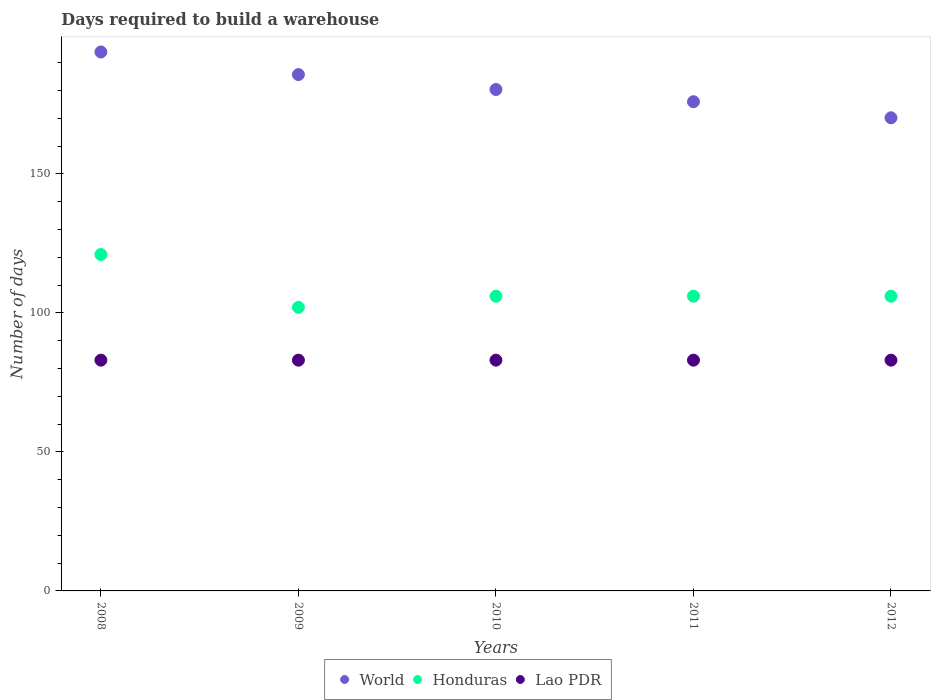What is the days required to build a warehouse in in Honduras in 2011?
Ensure brevity in your answer.  106. Across all years, what is the maximum days required to build a warehouse in in Lao PDR?
Give a very brief answer. 83. Across all years, what is the minimum days required to build a warehouse in in Honduras?
Offer a terse response. 102. What is the total days required to build a warehouse in in World in the graph?
Your response must be concise. 906.04. What is the difference between the days required to build a warehouse in in World in 2011 and that in 2012?
Provide a short and direct response. 5.78. What is the difference between the days required to build a warehouse in in Honduras in 2008 and the days required to build a warehouse in in Lao PDR in 2009?
Offer a very short reply. 38. What is the average days required to build a warehouse in in World per year?
Your answer should be compact. 181.21. In the year 2008, what is the difference between the days required to build a warehouse in in Honduras and days required to build a warehouse in in World?
Provide a short and direct response. -72.84. In how many years, is the days required to build a warehouse in in World greater than 140 days?
Ensure brevity in your answer.  5. Is the difference between the days required to build a warehouse in in Honduras in 2010 and 2011 greater than the difference between the days required to build a warehouse in in World in 2010 and 2011?
Offer a terse response. No. What is the difference between the highest and the second highest days required to build a warehouse in in World?
Your response must be concise. 8.13. What is the difference between the highest and the lowest days required to build a warehouse in in Honduras?
Provide a succinct answer. 19. In how many years, is the days required to build a warehouse in in Honduras greater than the average days required to build a warehouse in in Honduras taken over all years?
Provide a short and direct response. 1. Is it the case that in every year, the sum of the days required to build a warehouse in in World and days required to build a warehouse in in Honduras  is greater than the days required to build a warehouse in in Lao PDR?
Provide a short and direct response. Yes. Is the days required to build a warehouse in in Honduras strictly greater than the days required to build a warehouse in in Lao PDR over the years?
Your response must be concise. Yes. How many dotlines are there?
Your response must be concise. 3. How many years are there in the graph?
Your response must be concise. 5. Does the graph contain grids?
Your answer should be very brief. No. How are the legend labels stacked?
Make the answer very short. Horizontal. What is the title of the graph?
Give a very brief answer. Days required to build a warehouse. What is the label or title of the Y-axis?
Your answer should be compact. Number of days. What is the Number of days in World in 2008?
Provide a short and direct response. 193.84. What is the Number of days in Honduras in 2008?
Offer a very short reply. 121. What is the Number of days of Lao PDR in 2008?
Make the answer very short. 83. What is the Number of days of World in 2009?
Your answer should be very brief. 185.71. What is the Number of days in Honduras in 2009?
Your response must be concise. 102. What is the Number of days of World in 2010?
Offer a very short reply. 180.35. What is the Number of days of Honduras in 2010?
Your response must be concise. 106. What is the Number of days of World in 2011?
Provide a short and direct response. 175.96. What is the Number of days in Honduras in 2011?
Ensure brevity in your answer.  106. What is the Number of days of World in 2012?
Make the answer very short. 170.18. What is the Number of days in Honduras in 2012?
Offer a terse response. 106. What is the Number of days of Lao PDR in 2012?
Offer a terse response. 83. Across all years, what is the maximum Number of days of World?
Give a very brief answer. 193.84. Across all years, what is the maximum Number of days in Honduras?
Give a very brief answer. 121. Across all years, what is the minimum Number of days in World?
Offer a very short reply. 170.18. Across all years, what is the minimum Number of days of Honduras?
Your answer should be compact. 102. Across all years, what is the minimum Number of days in Lao PDR?
Your answer should be compact. 83. What is the total Number of days of World in the graph?
Offer a very short reply. 906.04. What is the total Number of days in Honduras in the graph?
Your answer should be very brief. 541. What is the total Number of days in Lao PDR in the graph?
Give a very brief answer. 415. What is the difference between the Number of days of World in 2008 and that in 2009?
Your answer should be very brief. 8.13. What is the difference between the Number of days in Lao PDR in 2008 and that in 2009?
Offer a terse response. 0. What is the difference between the Number of days in World in 2008 and that in 2010?
Make the answer very short. 13.49. What is the difference between the Number of days of Lao PDR in 2008 and that in 2010?
Offer a terse response. 0. What is the difference between the Number of days in World in 2008 and that in 2011?
Offer a very short reply. 17.89. What is the difference between the Number of days of Honduras in 2008 and that in 2011?
Offer a very short reply. 15. What is the difference between the Number of days of Lao PDR in 2008 and that in 2011?
Keep it short and to the point. 0. What is the difference between the Number of days in World in 2008 and that in 2012?
Offer a very short reply. 23.67. What is the difference between the Number of days in Honduras in 2008 and that in 2012?
Your answer should be compact. 15. What is the difference between the Number of days of World in 2009 and that in 2010?
Offer a very short reply. 5.36. What is the difference between the Number of days of Honduras in 2009 and that in 2010?
Your answer should be very brief. -4. What is the difference between the Number of days in World in 2009 and that in 2011?
Make the answer very short. 9.76. What is the difference between the Number of days of World in 2009 and that in 2012?
Ensure brevity in your answer.  15.54. What is the difference between the Number of days in World in 2010 and that in 2011?
Make the answer very short. 4.4. What is the difference between the Number of days of Honduras in 2010 and that in 2011?
Ensure brevity in your answer.  0. What is the difference between the Number of days in Lao PDR in 2010 and that in 2011?
Your answer should be compact. 0. What is the difference between the Number of days in World in 2010 and that in 2012?
Make the answer very short. 10.18. What is the difference between the Number of days of Lao PDR in 2010 and that in 2012?
Offer a terse response. 0. What is the difference between the Number of days in World in 2011 and that in 2012?
Give a very brief answer. 5.78. What is the difference between the Number of days in Honduras in 2011 and that in 2012?
Give a very brief answer. 0. What is the difference between the Number of days in World in 2008 and the Number of days in Honduras in 2009?
Ensure brevity in your answer.  91.84. What is the difference between the Number of days in World in 2008 and the Number of days in Lao PDR in 2009?
Your response must be concise. 110.84. What is the difference between the Number of days in World in 2008 and the Number of days in Honduras in 2010?
Provide a succinct answer. 87.84. What is the difference between the Number of days in World in 2008 and the Number of days in Lao PDR in 2010?
Your answer should be compact. 110.84. What is the difference between the Number of days of World in 2008 and the Number of days of Honduras in 2011?
Provide a short and direct response. 87.84. What is the difference between the Number of days in World in 2008 and the Number of days in Lao PDR in 2011?
Give a very brief answer. 110.84. What is the difference between the Number of days in World in 2008 and the Number of days in Honduras in 2012?
Provide a short and direct response. 87.84. What is the difference between the Number of days of World in 2008 and the Number of days of Lao PDR in 2012?
Offer a very short reply. 110.84. What is the difference between the Number of days of Honduras in 2008 and the Number of days of Lao PDR in 2012?
Provide a succinct answer. 38. What is the difference between the Number of days of World in 2009 and the Number of days of Honduras in 2010?
Ensure brevity in your answer.  79.71. What is the difference between the Number of days in World in 2009 and the Number of days in Lao PDR in 2010?
Give a very brief answer. 102.71. What is the difference between the Number of days of World in 2009 and the Number of days of Honduras in 2011?
Your answer should be compact. 79.71. What is the difference between the Number of days in World in 2009 and the Number of days in Lao PDR in 2011?
Make the answer very short. 102.71. What is the difference between the Number of days in Honduras in 2009 and the Number of days in Lao PDR in 2011?
Your answer should be very brief. 19. What is the difference between the Number of days in World in 2009 and the Number of days in Honduras in 2012?
Keep it short and to the point. 79.71. What is the difference between the Number of days in World in 2009 and the Number of days in Lao PDR in 2012?
Make the answer very short. 102.71. What is the difference between the Number of days of World in 2010 and the Number of days of Honduras in 2011?
Your response must be concise. 74.35. What is the difference between the Number of days in World in 2010 and the Number of days in Lao PDR in 2011?
Give a very brief answer. 97.35. What is the difference between the Number of days in Honduras in 2010 and the Number of days in Lao PDR in 2011?
Keep it short and to the point. 23. What is the difference between the Number of days of World in 2010 and the Number of days of Honduras in 2012?
Your response must be concise. 74.35. What is the difference between the Number of days of World in 2010 and the Number of days of Lao PDR in 2012?
Give a very brief answer. 97.35. What is the difference between the Number of days of Honduras in 2010 and the Number of days of Lao PDR in 2012?
Your answer should be compact. 23. What is the difference between the Number of days in World in 2011 and the Number of days in Honduras in 2012?
Make the answer very short. 69.96. What is the difference between the Number of days of World in 2011 and the Number of days of Lao PDR in 2012?
Provide a short and direct response. 92.96. What is the average Number of days of World per year?
Provide a short and direct response. 181.21. What is the average Number of days in Honduras per year?
Your answer should be very brief. 108.2. What is the average Number of days of Lao PDR per year?
Make the answer very short. 83. In the year 2008, what is the difference between the Number of days of World and Number of days of Honduras?
Make the answer very short. 72.84. In the year 2008, what is the difference between the Number of days of World and Number of days of Lao PDR?
Provide a succinct answer. 110.84. In the year 2009, what is the difference between the Number of days of World and Number of days of Honduras?
Make the answer very short. 83.71. In the year 2009, what is the difference between the Number of days in World and Number of days in Lao PDR?
Your answer should be very brief. 102.71. In the year 2010, what is the difference between the Number of days in World and Number of days in Honduras?
Provide a short and direct response. 74.35. In the year 2010, what is the difference between the Number of days in World and Number of days in Lao PDR?
Keep it short and to the point. 97.35. In the year 2011, what is the difference between the Number of days of World and Number of days of Honduras?
Keep it short and to the point. 69.96. In the year 2011, what is the difference between the Number of days in World and Number of days in Lao PDR?
Give a very brief answer. 92.96. In the year 2011, what is the difference between the Number of days of Honduras and Number of days of Lao PDR?
Your answer should be very brief. 23. In the year 2012, what is the difference between the Number of days in World and Number of days in Honduras?
Your answer should be very brief. 64.18. In the year 2012, what is the difference between the Number of days of World and Number of days of Lao PDR?
Make the answer very short. 87.18. In the year 2012, what is the difference between the Number of days of Honduras and Number of days of Lao PDR?
Provide a succinct answer. 23. What is the ratio of the Number of days in World in 2008 to that in 2009?
Provide a short and direct response. 1.04. What is the ratio of the Number of days in Honduras in 2008 to that in 2009?
Offer a terse response. 1.19. What is the ratio of the Number of days in Lao PDR in 2008 to that in 2009?
Provide a succinct answer. 1. What is the ratio of the Number of days of World in 2008 to that in 2010?
Ensure brevity in your answer.  1.07. What is the ratio of the Number of days of Honduras in 2008 to that in 2010?
Offer a very short reply. 1.14. What is the ratio of the Number of days of Lao PDR in 2008 to that in 2010?
Give a very brief answer. 1. What is the ratio of the Number of days in World in 2008 to that in 2011?
Make the answer very short. 1.1. What is the ratio of the Number of days in Honduras in 2008 to that in 2011?
Provide a succinct answer. 1.14. What is the ratio of the Number of days of World in 2008 to that in 2012?
Keep it short and to the point. 1.14. What is the ratio of the Number of days of Honduras in 2008 to that in 2012?
Give a very brief answer. 1.14. What is the ratio of the Number of days in World in 2009 to that in 2010?
Make the answer very short. 1.03. What is the ratio of the Number of days in Honduras in 2009 to that in 2010?
Offer a very short reply. 0.96. What is the ratio of the Number of days of World in 2009 to that in 2011?
Provide a succinct answer. 1.06. What is the ratio of the Number of days of Honduras in 2009 to that in 2011?
Provide a succinct answer. 0.96. What is the ratio of the Number of days of Lao PDR in 2009 to that in 2011?
Make the answer very short. 1. What is the ratio of the Number of days in World in 2009 to that in 2012?
Keep it short and to the point. 1.09. What is the ratio of the Number of days in Honduras in 2009 to that in 2012?
Provide a succinct answer. 0.96. What is the ratio of the Number of days of Lao PDR in 2009 to that in 2012?
Keep it short and to the point. 1. What is the ratio of the Number of days of Honduras in 2010 to that in 2011?
Keep it short and to the point. 1. What is the ratio of the Number of days of World in 2010 to that in 2012?
Ensure brevity in your answer.  1.06. What is the ratio of the Number of days in Honduras in 2010 to that in 2012?
Your answer should be very brief. 1. What is the ratio of the Number of days of Lao PDR in 2010 to that in 2012?
Make the answer very short. 1. What is the ratio of the Number of days of World in 2011 to that in 2012?
Make the answer very short. 1.03. What is the ratio of the Number of days in Lao PDR in 2011 to that in 2012?
Your answer should be very brief. 1. What is the difference between the highest and the second highest Number of days in World?
Make the answer very short. 8.13. What is the difference between the highest and the second highest Number of days of Honduras?
Ensure brevity in your answer.  15. What is the difference between the highest and the second highest Number of days of Lao PDR?
Offer a terse response. 0. What is the difference between the highest and the lowest Number of days of World?
Ensure brevity in your answer.  23.67. What is the difference between the highest and the lowest Number of days of Honduras?
Provide a short and direct response. 19. What is the difference between the highest and the lowest Number of days in Lao PDR?
Ensure brevity in your answer.  0. 